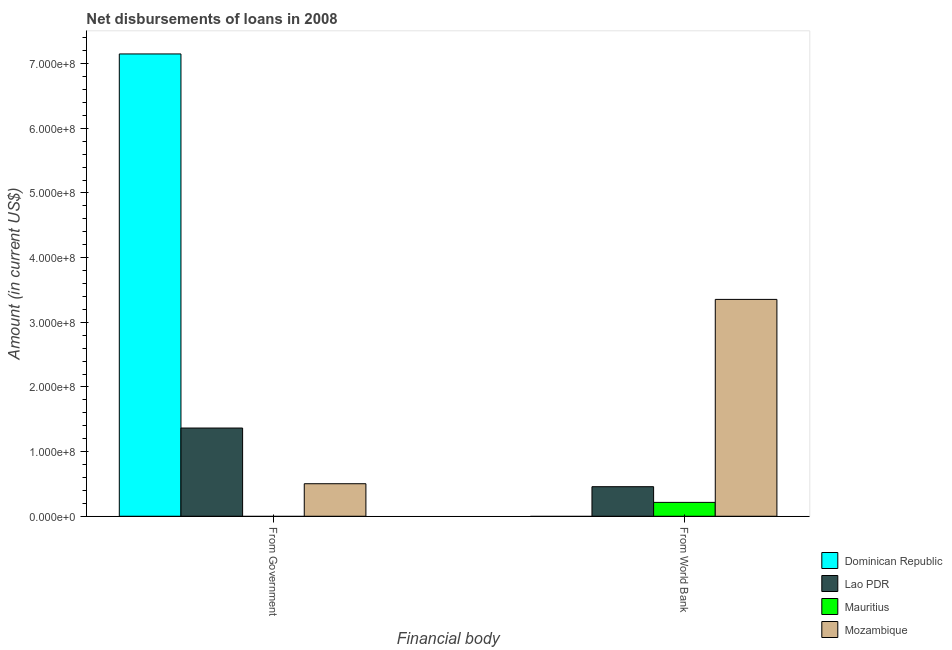How many different coloured bars are there?
Provide a short and direct response. 4. How many groups of bars are there?
Keep it short and to the point. 2. How many bars are there on the 1st tick from the left?
Make the answer very short. 3. What is the label of the 1st group of bars from the left?
Provide a short and direct response. From Government. What is the net disbursements of loan from government in Lao PDR?
Your answer should be very brief. 1.36e+08. Across all countries, what is the maximum net disbursements of loan from government?
Offer a very short reply. 7.15e+08. In which country was the net disbursements of loan from world bank maximum?
Provide a succinct answer. Mozambique. What is the total net disbursements of loan from government in the graph?
Offer a very short reply. 9.02e+08. What is the difference between the net disbursements of loan from world bank in Mozambique and that in Mauritius?
Provide a short and direct response. 3.14e+08. What is the difference between the net disbursements of loan from world bank in Mozambique and the net disbursements of loan from government in Mauritius?
Offer a terse response. 3.35e+08. What is the average net disbursements of loan from government per country?
Offer a very short reply. 2.25e+08. What is the difference between the net disbursements of loan from world bank and net disbursements of loan from government in Mozambique?
Provide a succinct answer. 2.85e+08. What is the ratio of the net disbursements of loan from government in Dominican Republic to that in Lao PDR?
Your answer should be compact. 5.24. Is the net disbursements of loan from government in Mozambique less than that in Dominican Republic?
Your answer should be very brief. Yes. Does the graph contain any zero values?
Make the answer very short. Yes. Where does the legend appear in the graph?
Provide a short and direct response. Bottom right. What is the title of the graph?
Provide a succinct answer. Net disbursements of loans in 2008. What is the label or title of the X-axis?
Your answer should be compact. Financial body. What is the Amount (in current US$) of Dominican Republic in From Government?
Provide a short and direct response. 7.15e+08. What is the Amount (in current US$) of Lao PDR in From Government?
Provide a succinct answer. 1.36e+08. What is the Amount (in current US$) in Mozambique in From Government?
Give a very brief answer. 5.03e+07. What is the Amount (in current US$) of Lao PDR in From World Bank?
Make the answer very short. 4.57e+07. What is the Amount (in current US$) of Mauritius in From World Bank?
Give a very brief answer. 2.14e+07. What is the Amount (in current US$) in Mozambique in From World Bank?
Offer a terse response. 3.35e+08. Across all Financial body, what is the maximum Amount (in current US$) in Dominican Republic?
Ensure brevity in your answer.  7.15e+08. Across all Financial body, what is the maximum Amount (in current US$) of Lao PDR?
Provide a short and direct response. 1.36e+08. Across all Financial body, what is the maximum Amount (in current US$) in Mauritius?
Provide a short and direct response. 2.14e+07. Across all Financial body, what is the maximum Amount (in current US$) in Mozambique?
Provide a short and direct response. 3.35e+08. Across all Financial body, what is the minimum Amount (in current US$) in Dominican Republic?
Your answer should be very brief. 0. Across all Financial body, what is the minimum Amount (in current US$) of Lao PDR?
Keep it short and to the point. 4.57e+07. Across all Financial body, what is the minimum Amount (in current US$) of Mozambique?
Keep it short and to the point. 5.03e+07. What is the total Amount (in current US$) of Dominican Republic in the graph?
Ensure brevity in your answer.  7.15e+08. What is the total Amount (in current US$) of Lao PDR in the graph?
Keep it short and to the point. 1.82e+08. What is the total Amount (in current US$) in Mauritius in the graph?
Your answer should be very brief. 2.14e+07. What is the total Amount (in current US$) in Mozambique in the graph?
Give a very brief answer. 3.86e+08. What is the difference between the Amount (in current US$) of Lao PDR in From Government and that in From World Bank?
Ensure brevity in your answer.  9.07e+07. What is the difference between the Amount (in current US$) in Mozambique in From Government and that in From World Bank?
Provide a succinct answer. -2.85e+08. What is the difference between the Amount (in current US$) of Dominican Republic in From Government and the Amount (in current US$) of Lao PDR in From World Bank?
Your answer should be very brief. 6.69e+08. What is the difference between the Amount (in current US$) in Dominican Republic in From Government and the Amount (in current US$) in Mauritius in From World Bank?
Ensure brevity in your answer.  6.94e+08. What is the difference between the Amount (in current US$) in Dominican Republic in From Government and the Amount (in current US$) in Mozambique in From World Bank?
Your answer should be compact. 3.80e+08. What is the difference between the Amount (in current US$) of Lao PDR in From Government and the Amount (in current US$) of Mauritius in From World Bank?
Provide a short and direct response. 1.15e+08. What is the difference between the Amount (in current US$) of Lao PDR in From Government and the Amount (in current US$) of Mozambique in From World Bank?
Provide a succinct answer. -1.99e+08. What is the average Amount (in current US$) in Dominican Republic per Financial body?
Provide a short and direct response. 3.58e+08. What is the average Amount (in current US$) of Lao PDR per Financial body?
Your response must be concise. 9.11e+07. What is the average Amount (in current US$) of Mauritius per Financial body?
Give a very brief answer. 1.07e+07. What is the average Amount (in current US$) of Mozambique per Financial body?
Ensure brevity in your answer.  1.93e+08. What is the difference between the Amount (in current US$) of Dominican Republic and Amount (in current US$) of Lao PDR in From Government?
Give a very brief answer. 5.79e+08. What is the difference between the Amount (in current US$) of Dominican Republic and Amount (in current US$) of Mozambique in From Government?
Make the answer very short. 6.65e+08. What is the difference between the Amount (in current US$) of Lao PDR and Amount (in current US$) of Mozambique in From Government?
Provide a short and direct response. 8.61e+07. What is the difference between the Amount (in current US$) of Lao PDR and Amount (in current US$) of Mauritius in From World Bank?
Ensure brevity in your answer.  2.43e+07. What is the difference between the Amount (in current US$) of Lao PDR and Amount (in current US$) of Mozambique in From World Bank?
Make the answer very short. -2.90e+08. What is the difference between the Amount (in current US$) of Mauritius and Amount (in current US$) of Mozambique in From World Bank?
Ensure brevity in your answer.  -3.14e+08. What is the ratio of the Amount (in current US$) in Lao PDR in From Government to that in From World Bank?
Make the answer very short. 2.98. What is the difference between the highest and the second highest Amount (in current US$) of Lao PDR?
Make the answer very short. 9.07e+07. What is the difference between the highest and the second highest Amount (in current US$) in Mozambique?
Make the answer very short. 2.85e+08. What is the difference between the highest and the lowest Amount (in current US$) in Dominican Republic?
Provide a short and direct response. 7.15e+08. What is the difference between the highest and the lowest Amount (in current US$) in Lao PDR?
Give a very brief answer. 9.07e+07. What is the difference between the highest and the lowest Amount (in current US$) of Mauritius?
Give a very brief answer. 2.14e+07. What is the difference between the highest and the lowest Amount (in current US$) in Mozambique?
Make the answer very short. 2.85e+08. 